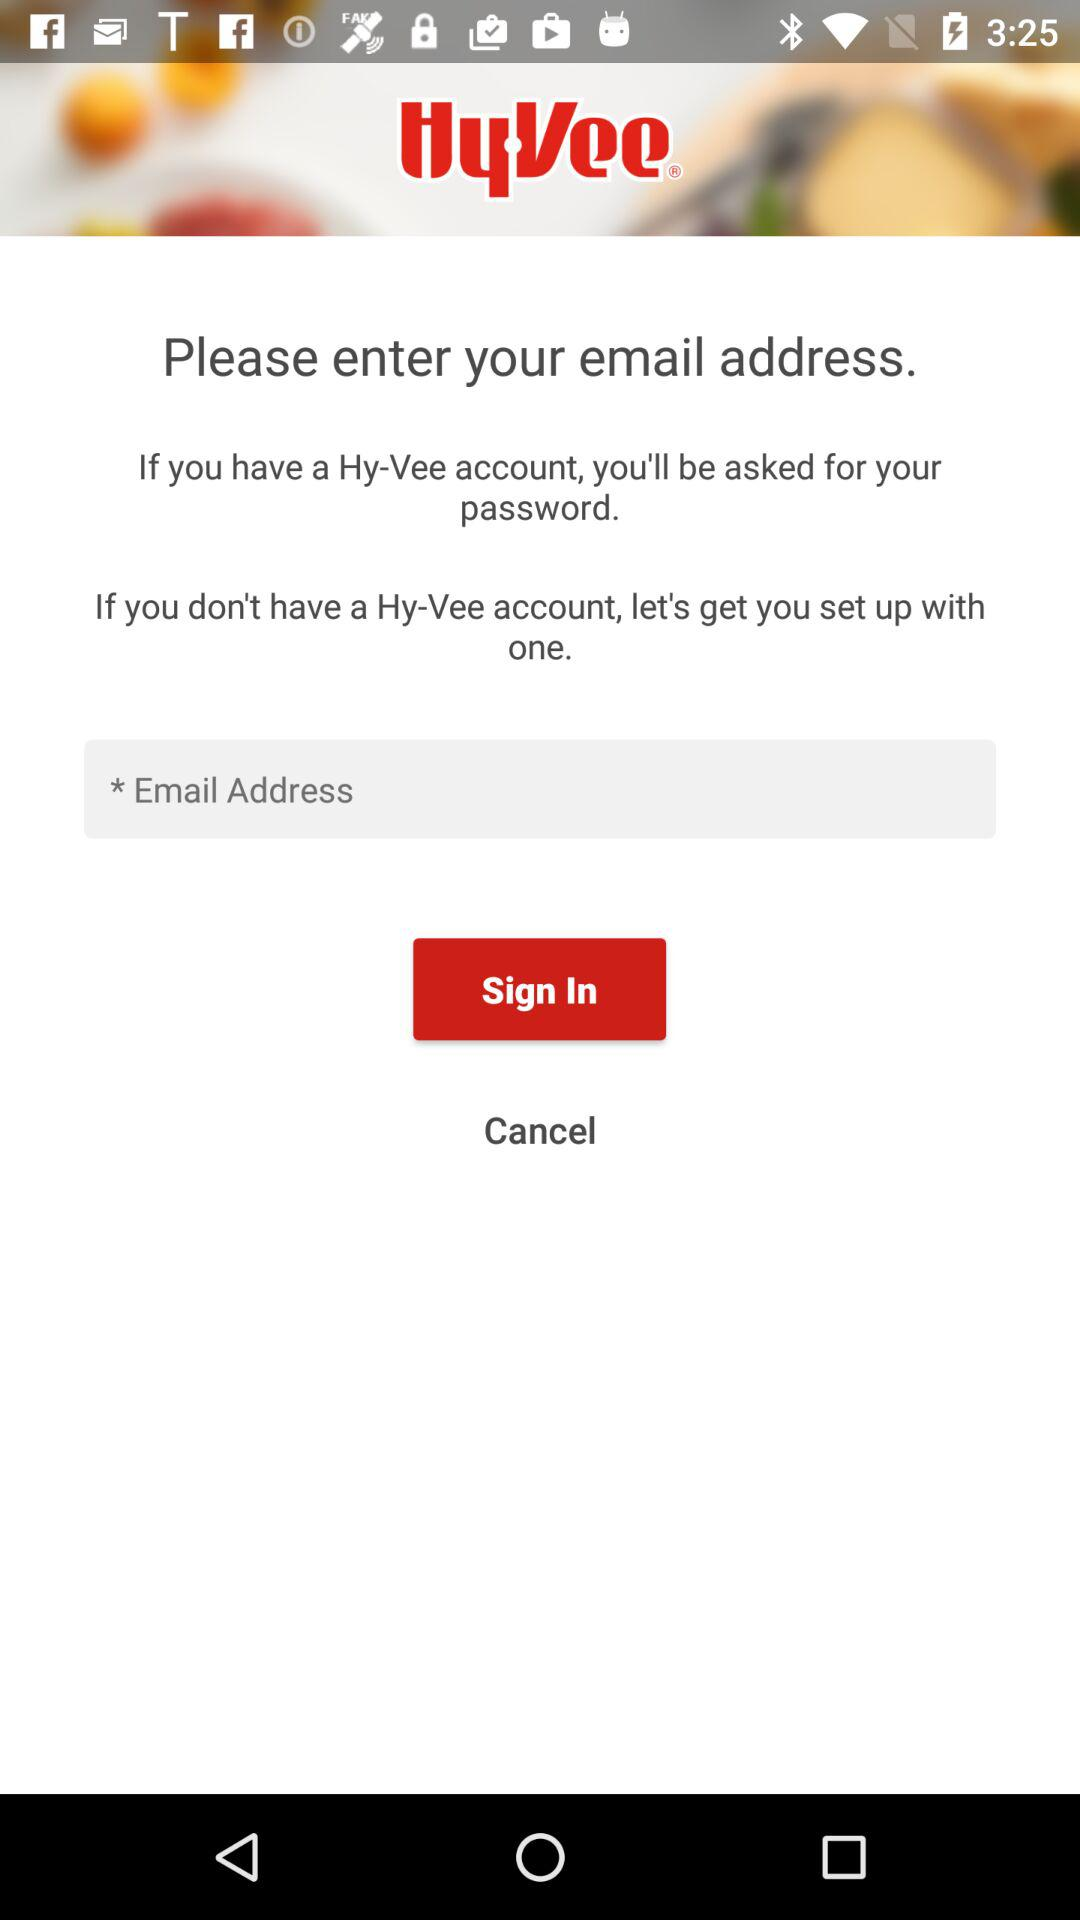What is the name of the application? The name of the application is "HyVee®". 